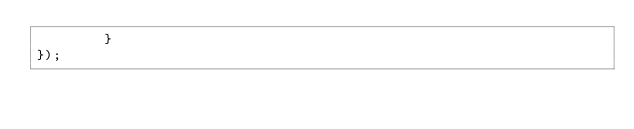<code> <loc_0><loc_0><loc_500><loc_500><_JavaScript_>        } 
});
</code> 